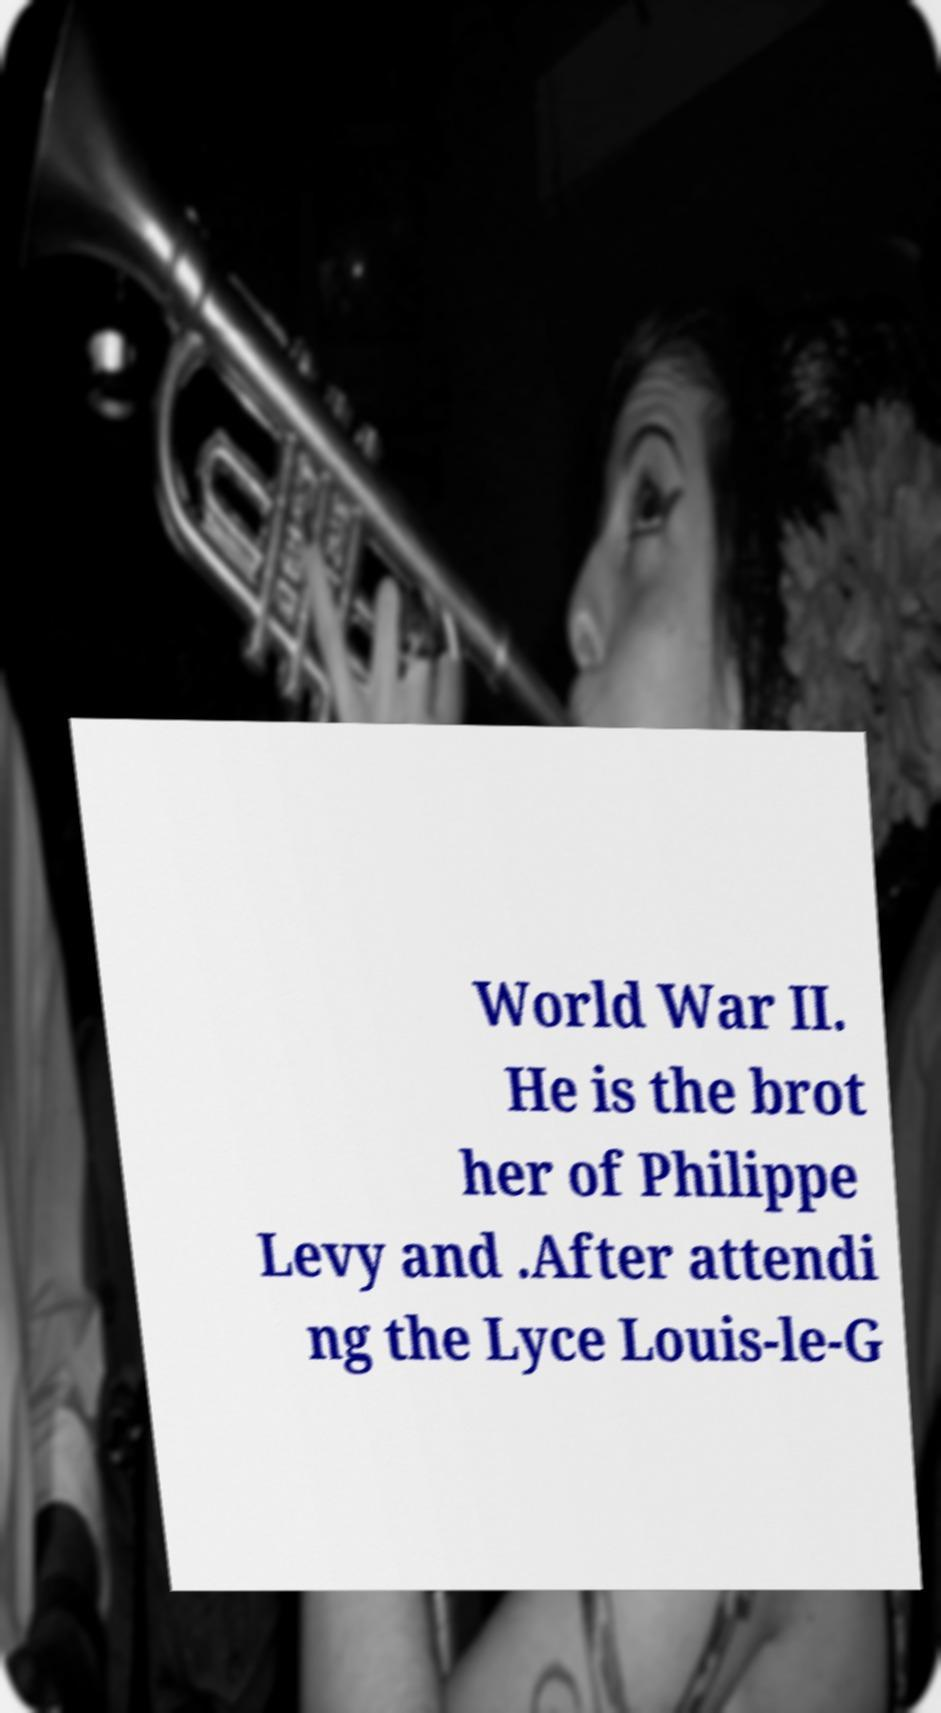There's text embedded in this image that I need extracted. Can you transcribe it verbatim? World War II. He is the brot her of Philippe Levy and .After attendi ng the Lyce Louis-le-G 